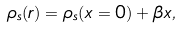<formula> <loc_0><loc_0><loc_500><loc_500>\rho _ { s } ( { r } ) = \rho _ { s } ( x = 0 ) + \beta x ,</formula> 